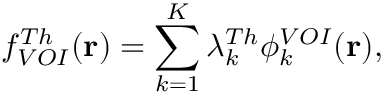<formula> <loc_0><loc_0><loc_500><loc_500>f _ { V O I } ^ { T h } ( r ) = \sum _ { k = 1 } ^ { K } \lambda _ { k } ^ { T h } \phi _ { k } ^ { V O I } ( r ) ,</formula> 